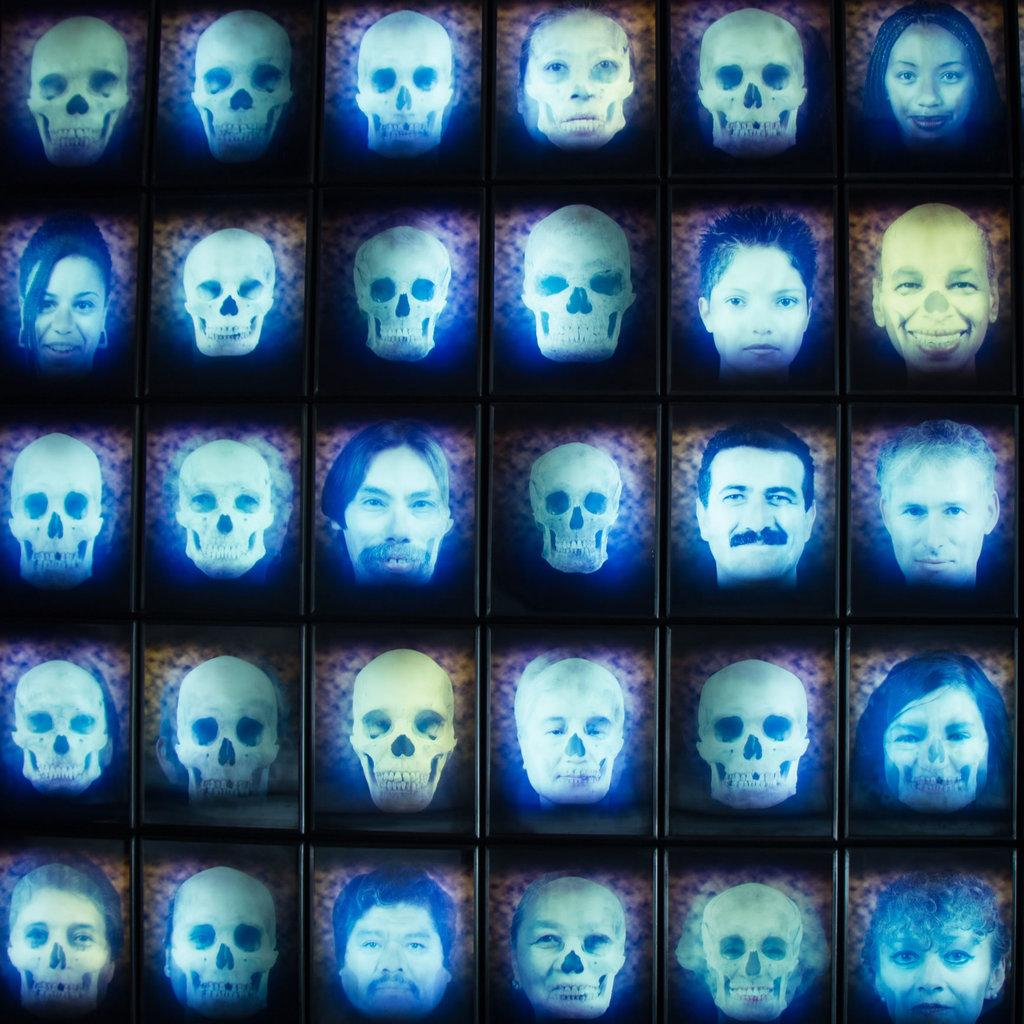What type of objects are in the image? There are blocks in the image. What is depicted on the blocks? There are skulls and human faces depicted on the blocks. What is the chance of a beetle crawling on the blocks in the image? There is no beetle present in the image, so it is not possible to determine the chance of one crawling on the blocks. 